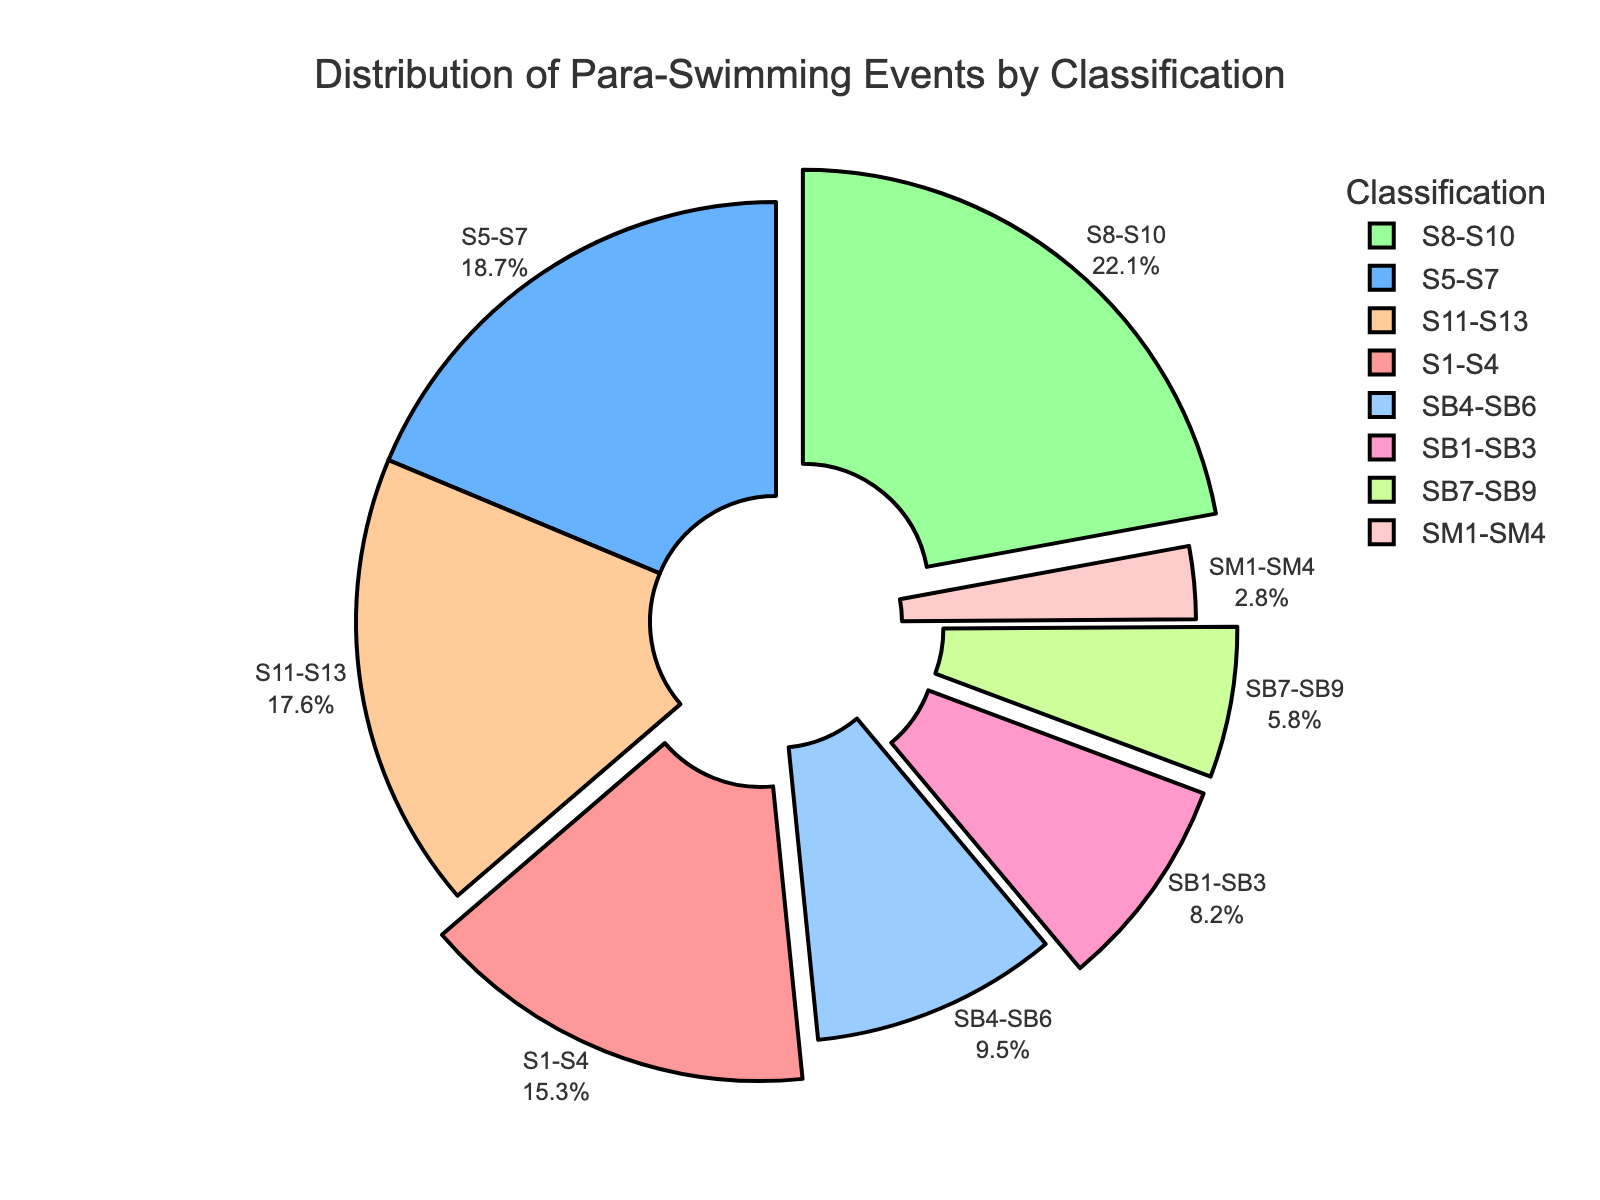What classification has the largest percentage of para-swimming events? The classification with the largest percentage of para-swimming events is represented by the largest slice of the pie chart. By examining the chart, we see that S8-S10 is the largest segment.
Answer: S8-S10 What is the combined percentage of events for S1-S4 and SM1-SM4 classifications? To find the combined percentage, add the percentages of S1-S4 and SM1-SM4. From the data, S1-S4 is 15.3% and SM1-SM4 is 2.8%. Therefore, 15.3 + 2.8 = 18.1%.
Answer: 18.1% Which classification has a higher percentage of events, SB4-SB6 or S11-S13? Compare the percentages of SB4-SB6 and S11-S13 from the pie chart. SB4-SB6 has 9.5% while S11-S13 has 17.6%, so S11-S13 has a higher percentage.
Answer: S11-S13 How much larger is the percentage of events for S8-S10 compared to SB7-SB9? Subtract the percentage of SB7-SB9 from that of S8-S10. The data shows S8-S10 is 22.1% and SB7-SB9 is 5.8%, so 22.1 - 5.8 = 16.3%.
Answer: 16.3% What is the total percentage of events for all S-classifications? Sum the percentages for S1-S4, S5-S7, S8-S10, and S11-S13. The data shows: 15.3% + 18.7% + 22.1% + 17.6%. Summing these gives 73.7%.
Answer: 73.7% Which classification has the smallest proportion of events? The smallest slice in the pie chart represents the classification with the least percentage, which is SM1-SM4 at 2.8%.
Answer: SM1-SM4 How does the percentage of SB1-SB3 compare to SB4-SB6? Compare the percentages from the pie chart. SB1-SB3 has 8.2% and SB4-SB6 has 9.5%, so SB4-SB6 has a higher percentage.
Answer: SB4-SB6 What is the combined percentage of all SB classifications (SB1-SB3, SB4-SB6, SB7-SB9)? Sum the percentages for SB classifications. From the data: 8.2% + 9.5% + 5.8% = 23.5%.
Answer: 23.5% Which classifications are represented by the segments that were pulled out of the chart? The segments pulled out are visually indicated by an offset from the pie chart. These classifications are S1-S4, S8-S10, SB1-SB3, and SM1-SM4.
Answer: S1-S4, S8-S10, SB1-SB3, SM1-SM4 